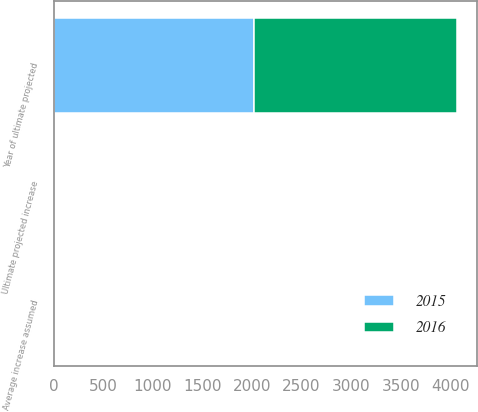Convert chart. <chart><loc_0><loc_0><loc_500><loc_500><stacked_bar_chart><ecel><fcel>Average increase assumed<fcel>Ultimate projected increase<fcel>Year of ultimate projected<nl><fcel>2016<fcel>6<fcel>5<fcel>2039<nl><fcel>2015<fcel>6<fcel>5<fcel>2025<nl></chart> 